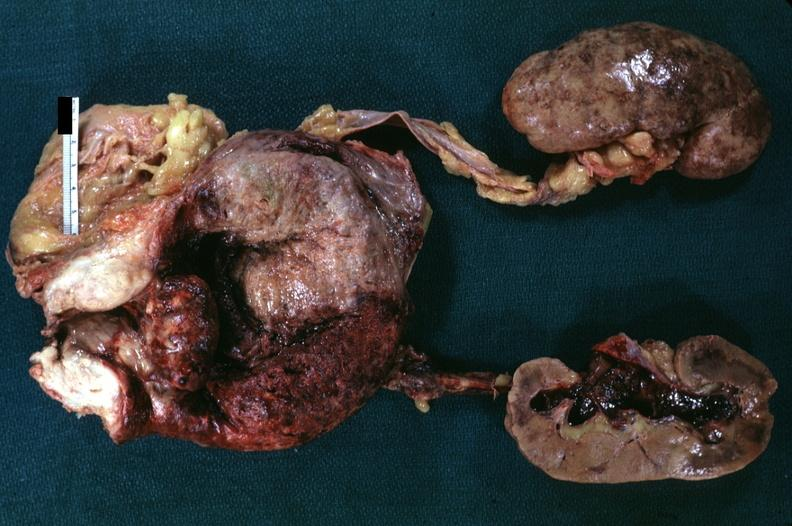what is present?
Answer the question using a single word or phrase. Hyperplasia 